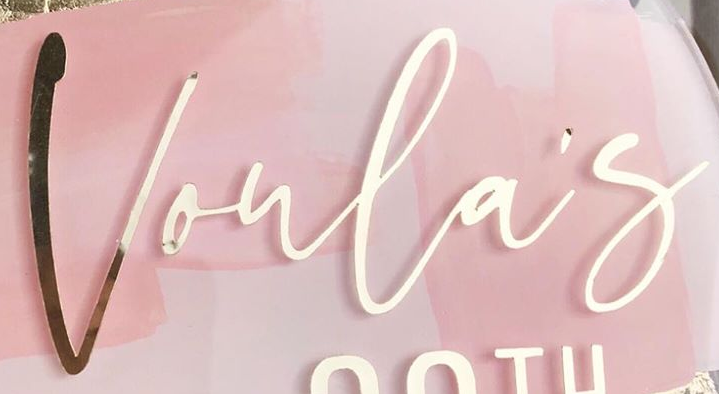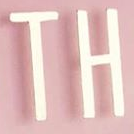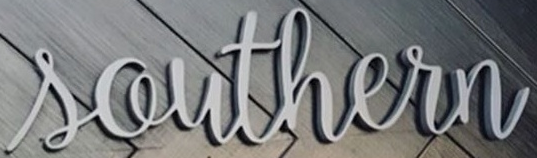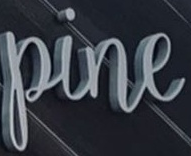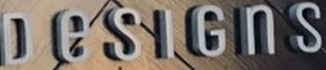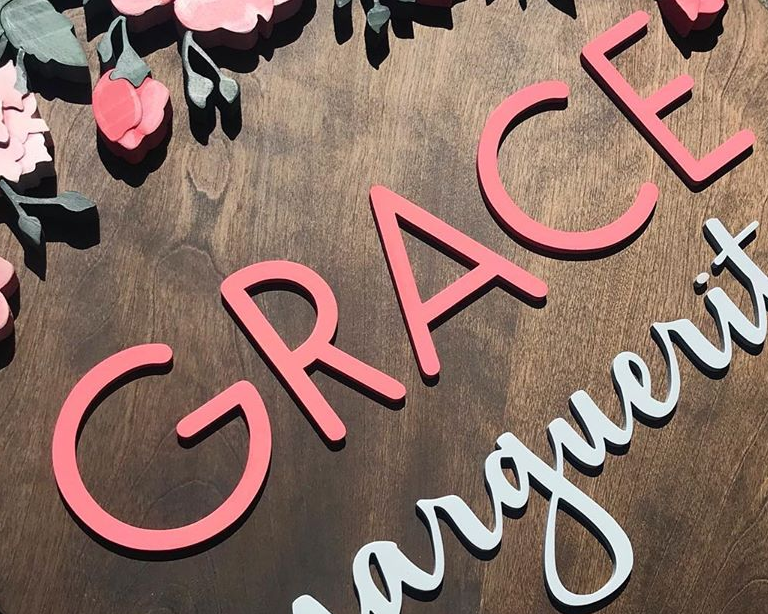Read the text from these images in sequence, separated by a semicolon. Voula's; TH; Southern; pine; DeSIGnS; GRACE 